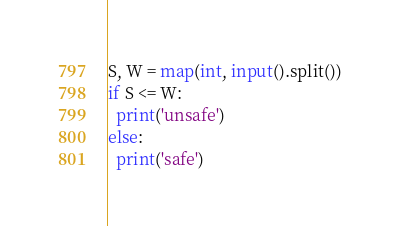Convert code to text. <code><loc_0><loc_0><loc_500><loc_500><_Python_>S, W = map(int, input().split())
if S <= W:
  print('unsafe')
else:
  print('safe')</code> 